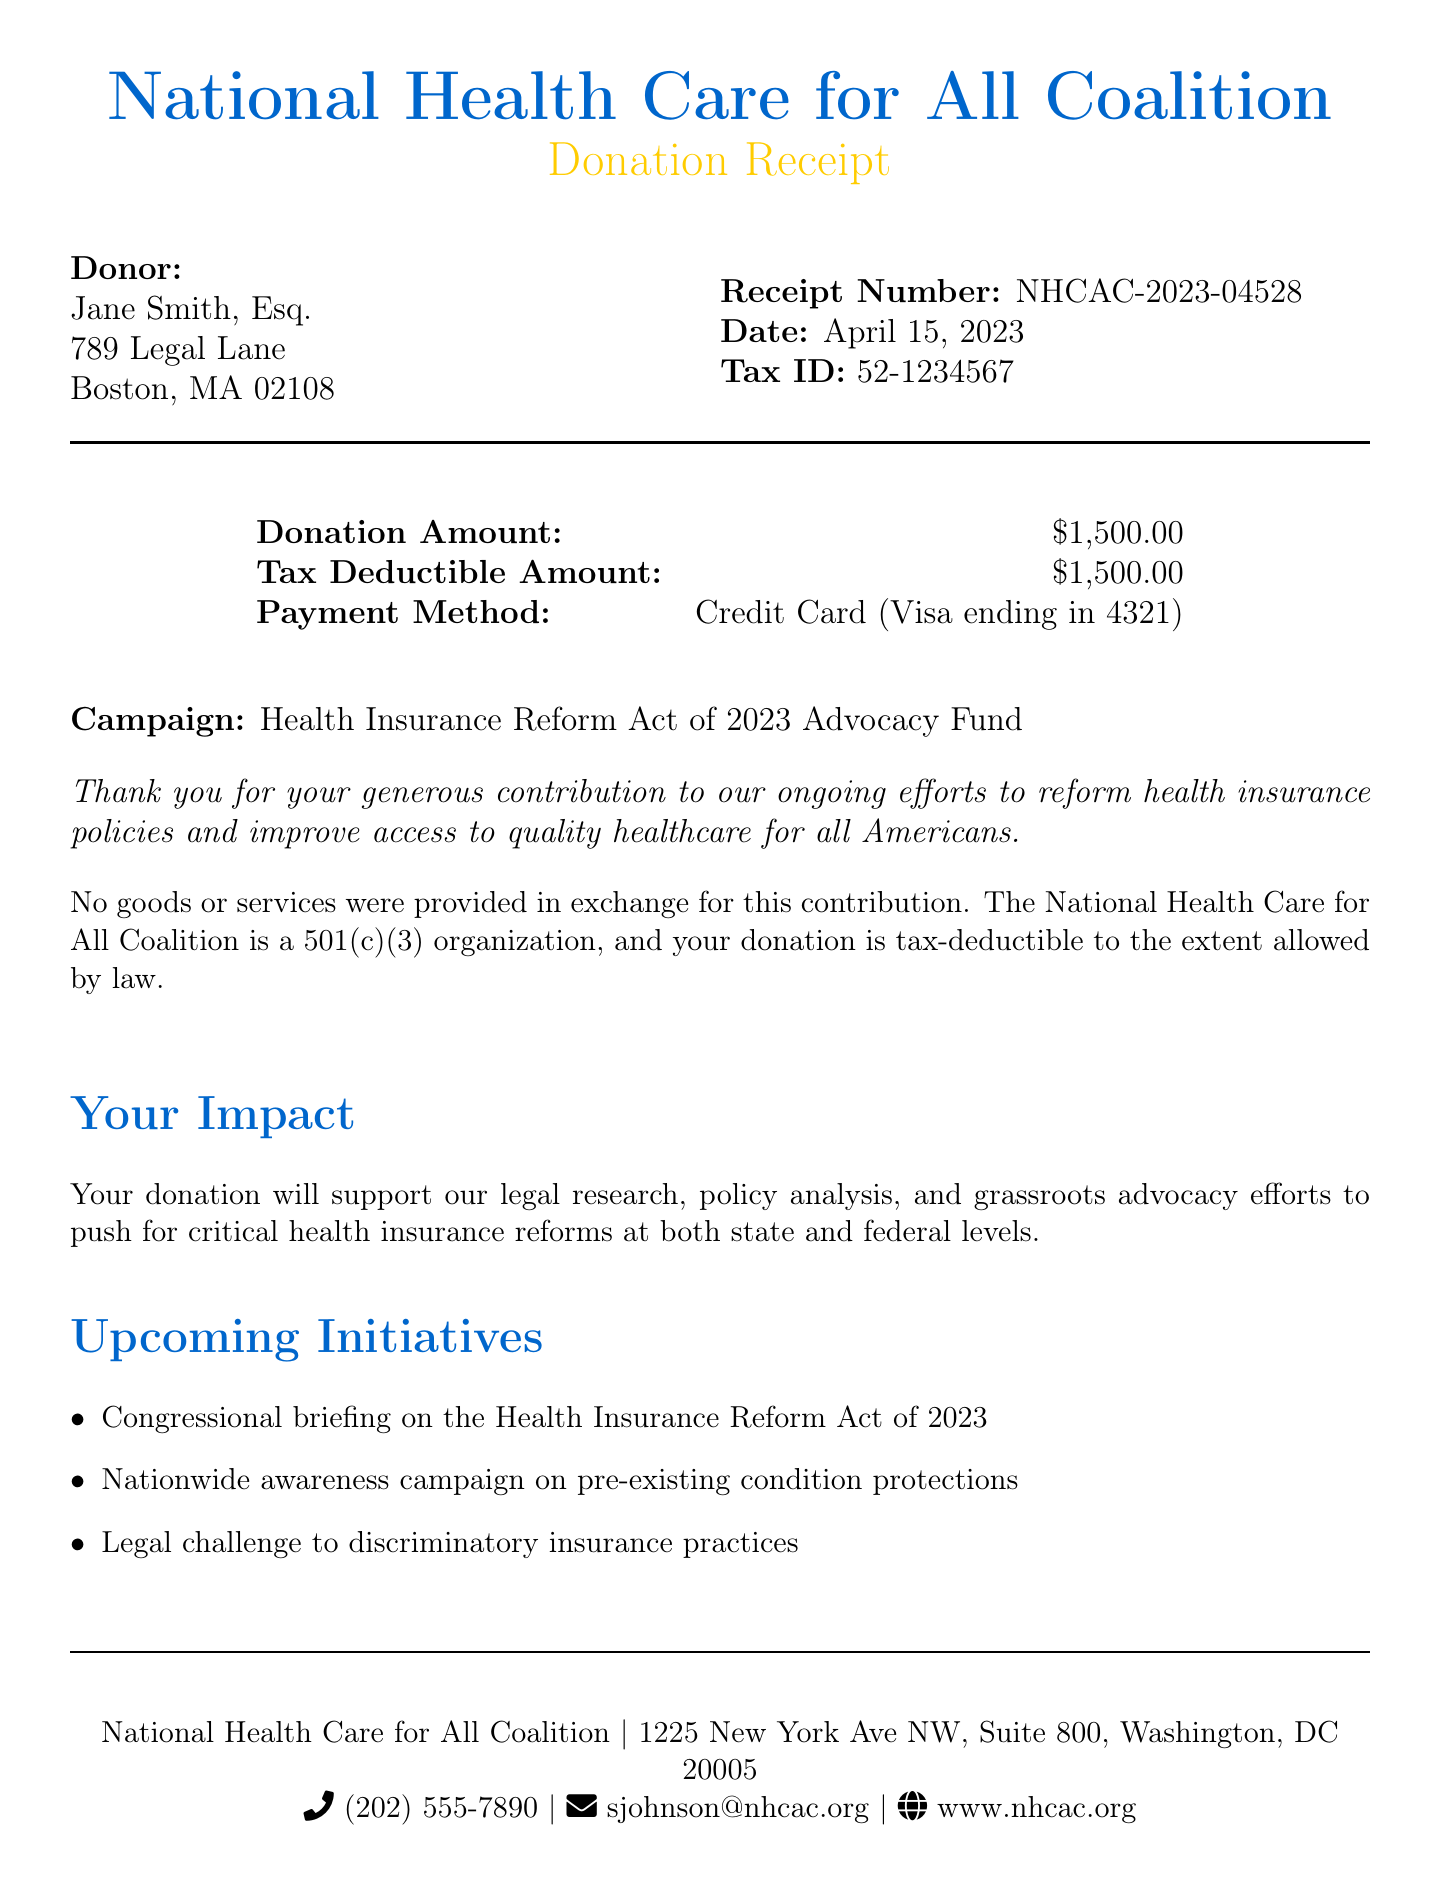What is the name of the organization? The document states the name of the organization as the National Health Care for All Coalition.
Answer: National Health Care for All Coalition What is the total donation amount? The donation amount mentioned in the document is clearly listed as $1,500.00.
Answer: $1,500.00 What is the receipt number? The specific receipt number assigned to this donation is noted in the document as NHCAC-2023-04528.
Answer: NHCAC-2023-04528 What portion of the donation is tax-deductible? The tax-deductible amount is also stated to be $1,500.00 in the document.
Answer: $1,500.00 Who is the donor? The document identifies the donor as Jane Smith, Esq.
Answer: Jane Smith, Esq What is the payment method used for this donation? The payment method indicated in the document is a Credit Card (Visa ending in 4321).
Answer: Credit Card (Visa ending in 4321) What is the campaign associated with the donation? The campaign for which the donation was made is referred to as the Health Insurance Reform Act of 2023 Advocacy Fund.
Answer: Health Insurance Reform Act of 2023 Advocacy Fund What is one benefit the donor receives? One of the benefits provided is stated to be quarterly policy briefings for the donor.
Answer: Quarterly policy briefings Was any goods or services received in exchange for the donation? The tax-deductibility statement confirms that no goods or services were provided in exchange for the donation.
Answer: No 